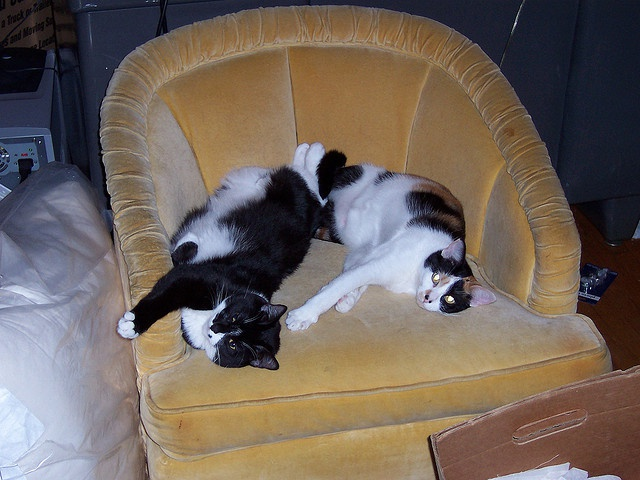Describe the objects in this image and their specific colors. I can see couch in black, tan, and gray tones, chair in black, tan, gray, and darkgray tones, cat in black, darkgray, and gray tones, and cat in black, darkgray, and lavender tones in this image. 